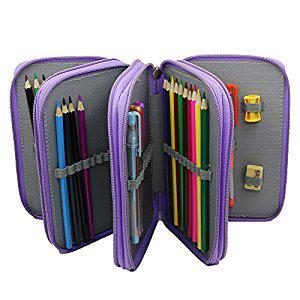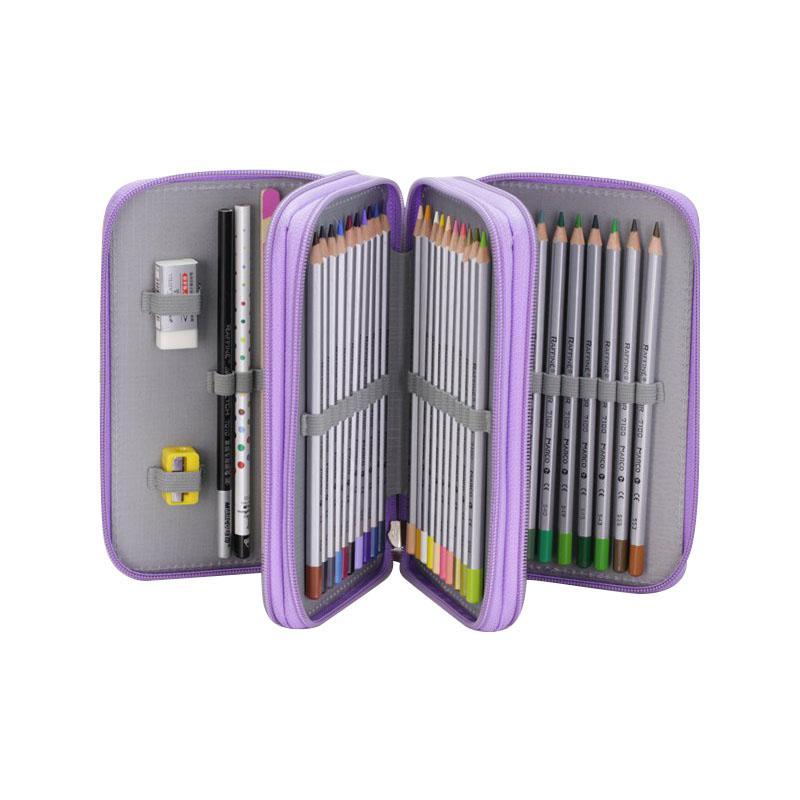The first image is the image on the left, the second image is the image on the right. Evaluate the accuracy of this statement regarding the images: "At least one of the pencil cases has a pencil sharpener fastened within.". Is it true? Answer yes or no. Yes. 